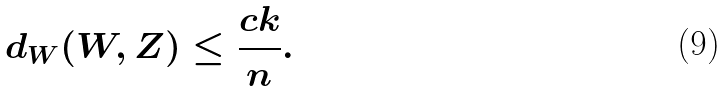<formula> <loc_0><loc_0><loc_500><loc_500>d _ { W } ( W , Z ) \leq \frac { c k } { n } .</formula> 